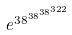<formula> <loc_0><loc_0><loc_500><loc_500>e ^ { 3 8 ^ { 3 8 ^ { 3 8 ^ { 3 2 2 } } } }</formula> 